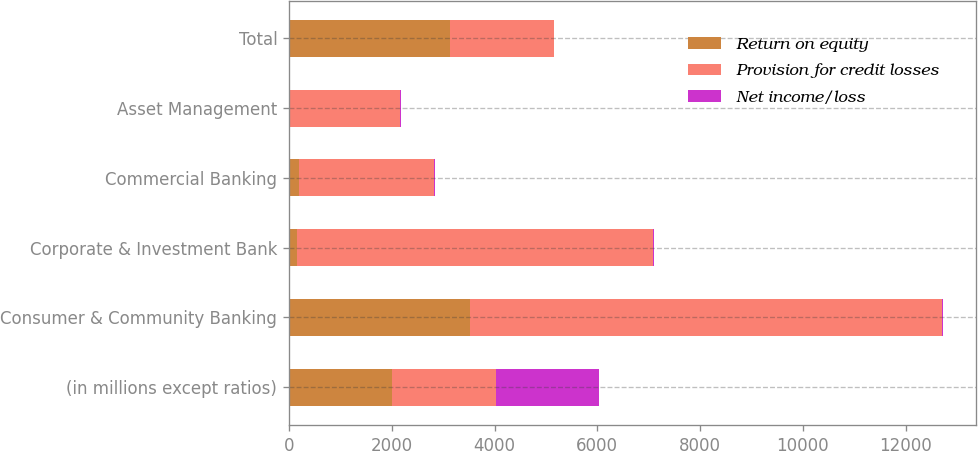Convert chart. <chart><loc_0><loc_0><loc_500><loc_500><stacked_bar_chart><ecel><fcel>(in millions except ratios)<fcel>Consumer & Community Banking<fcel>Corporate & Investment Bank<fcel>Commercial Banking<fcel>Asset Management<fcel>Total<nl><fcel>Return on equity<fcel>2014<fcel>3520<fcel>161<fcel>189<fcel>4<fcel>3139<nl><fcel>Provision for credit losses<fcel>2014<fcel>9185<fcel>6925<fcel>2635<fcel>2153<fcel>2014<nl><fcel>Net income/loss<fcel>2014<fcel>18<fcel>10<fcel>18<fcel>23<fcel>10<nl></chart> 